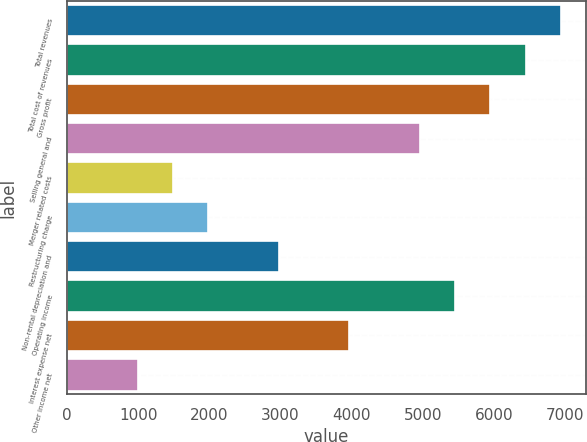Convert chart to OTSL. <chart><loc_0><loc_0><loc_500><loc_500><bar_chart><fcel>Total revenues<fcel>Total cost of revenues<fcel>Gross profit<fcel>Selling general and<fcel>Merger related costs<fcel>Restructuring charge<fcel>Non-rental depreciation and<fcel>Operating income<fcel>Interest expense net<fcel>Other income net<nl><fcel>6935.6<fcel>6440.46<fcel>5945.32<fcel>4955.04<fcel>1489.06<fcel>1984.2<fcel>2974.48<fcel>5450.18<fcel>3964.76<fcel>993.92<nl></chart> 